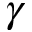Convert formula to latex. <formula><loc_0><loc_0><loc_500><loc_500>\gamma</formula> 